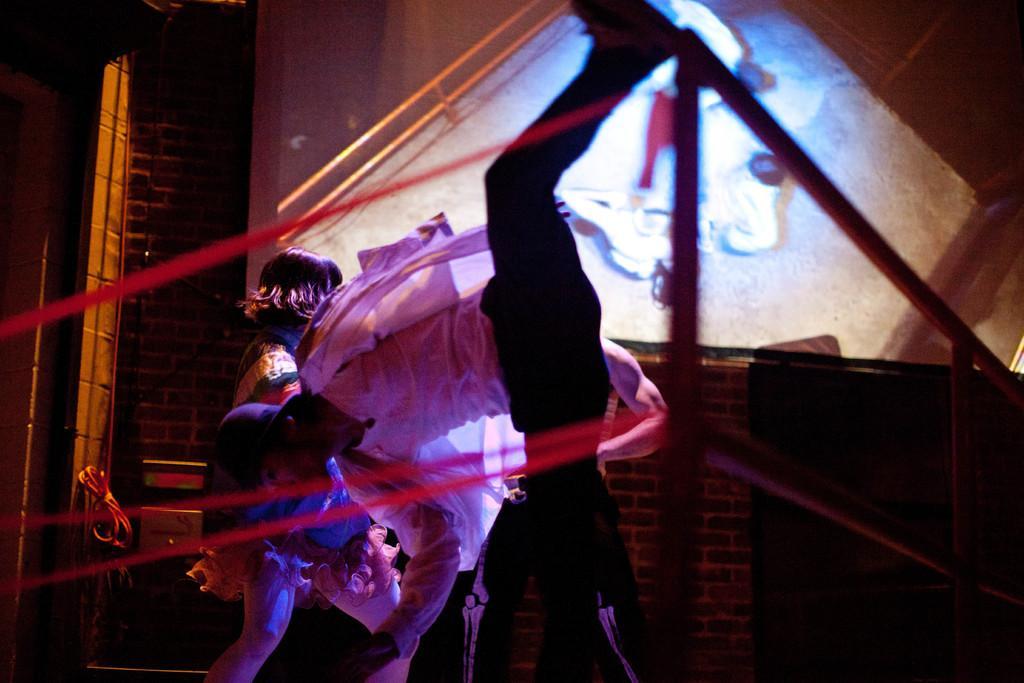How would you summarize this image in a sentence or two? In the middle a man is there, he wore a white color shirt and a black color trouser, in the left side there is a woman. 